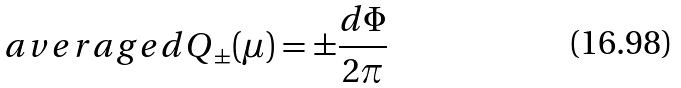Convert formula to latex. <formula><loc_0><loc_0><loc_500><loc_500>\ a v e r a g e { d Q } _ { \pm } ( \mu ) = \pm \frac { d \Phi } { 2 \pi }</formula> 